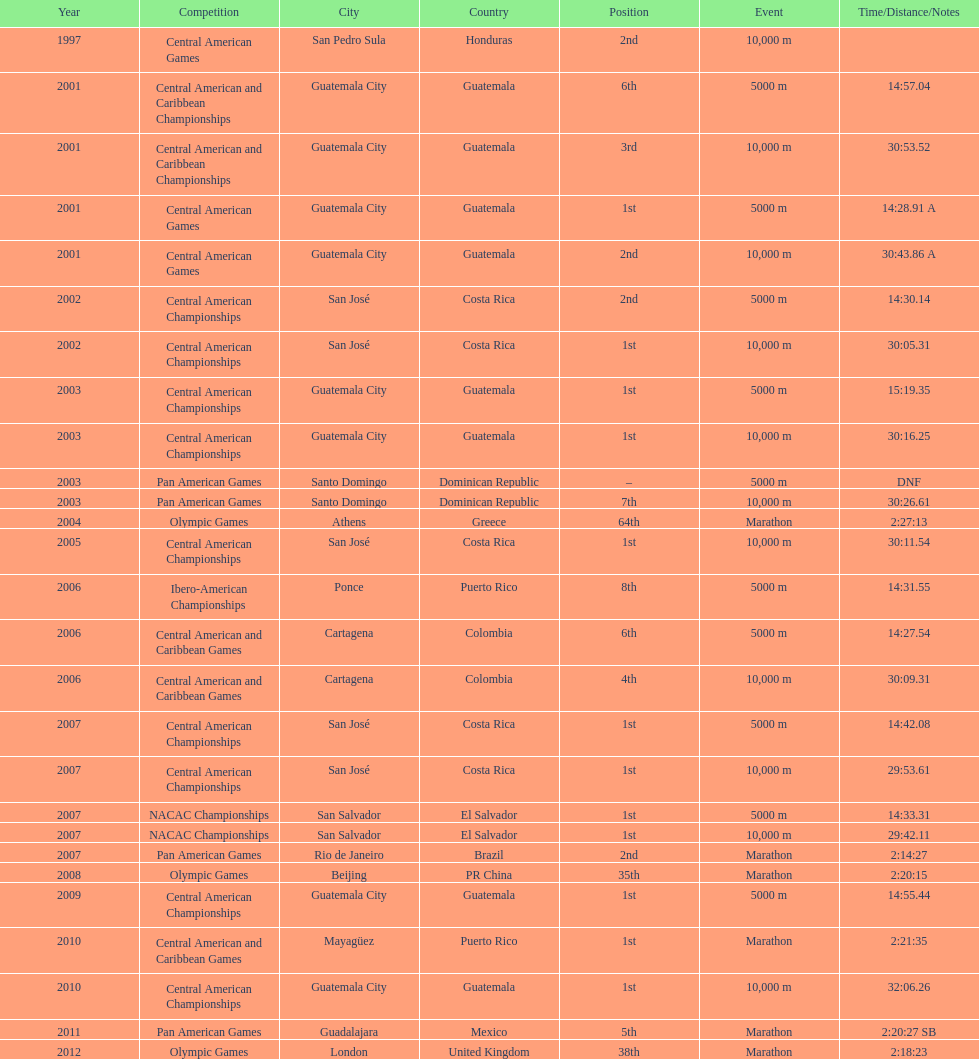How many times has the position of 1st been achieved? 12. 